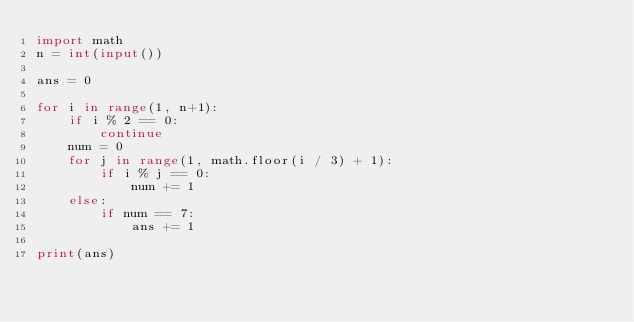Convert code to text. <code><loc_0><loc_0><loc_500><loc_500><_Python_>import math
n = int(input())

ans = 0

for i in range(1, n+1):
    if i % 2 == 0:
        continue
    num = 0
    for j in range(1, math.floor(i / 3) + 1):
        if i % j == 0:
            num += 1
    else:
        if num == 7:
            ans += 1

print(ans)
</code> 